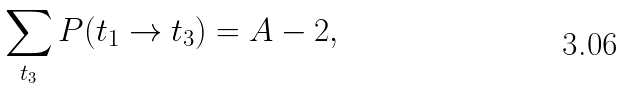Convert formula to latex. <formula><loc_0><loc_0><loc_500><loc_500>\sum _ { t _ { 3 } } P ( t _ { 1 } \rightarrow t _ { 3 } ) = A - 2 ,</formula> 